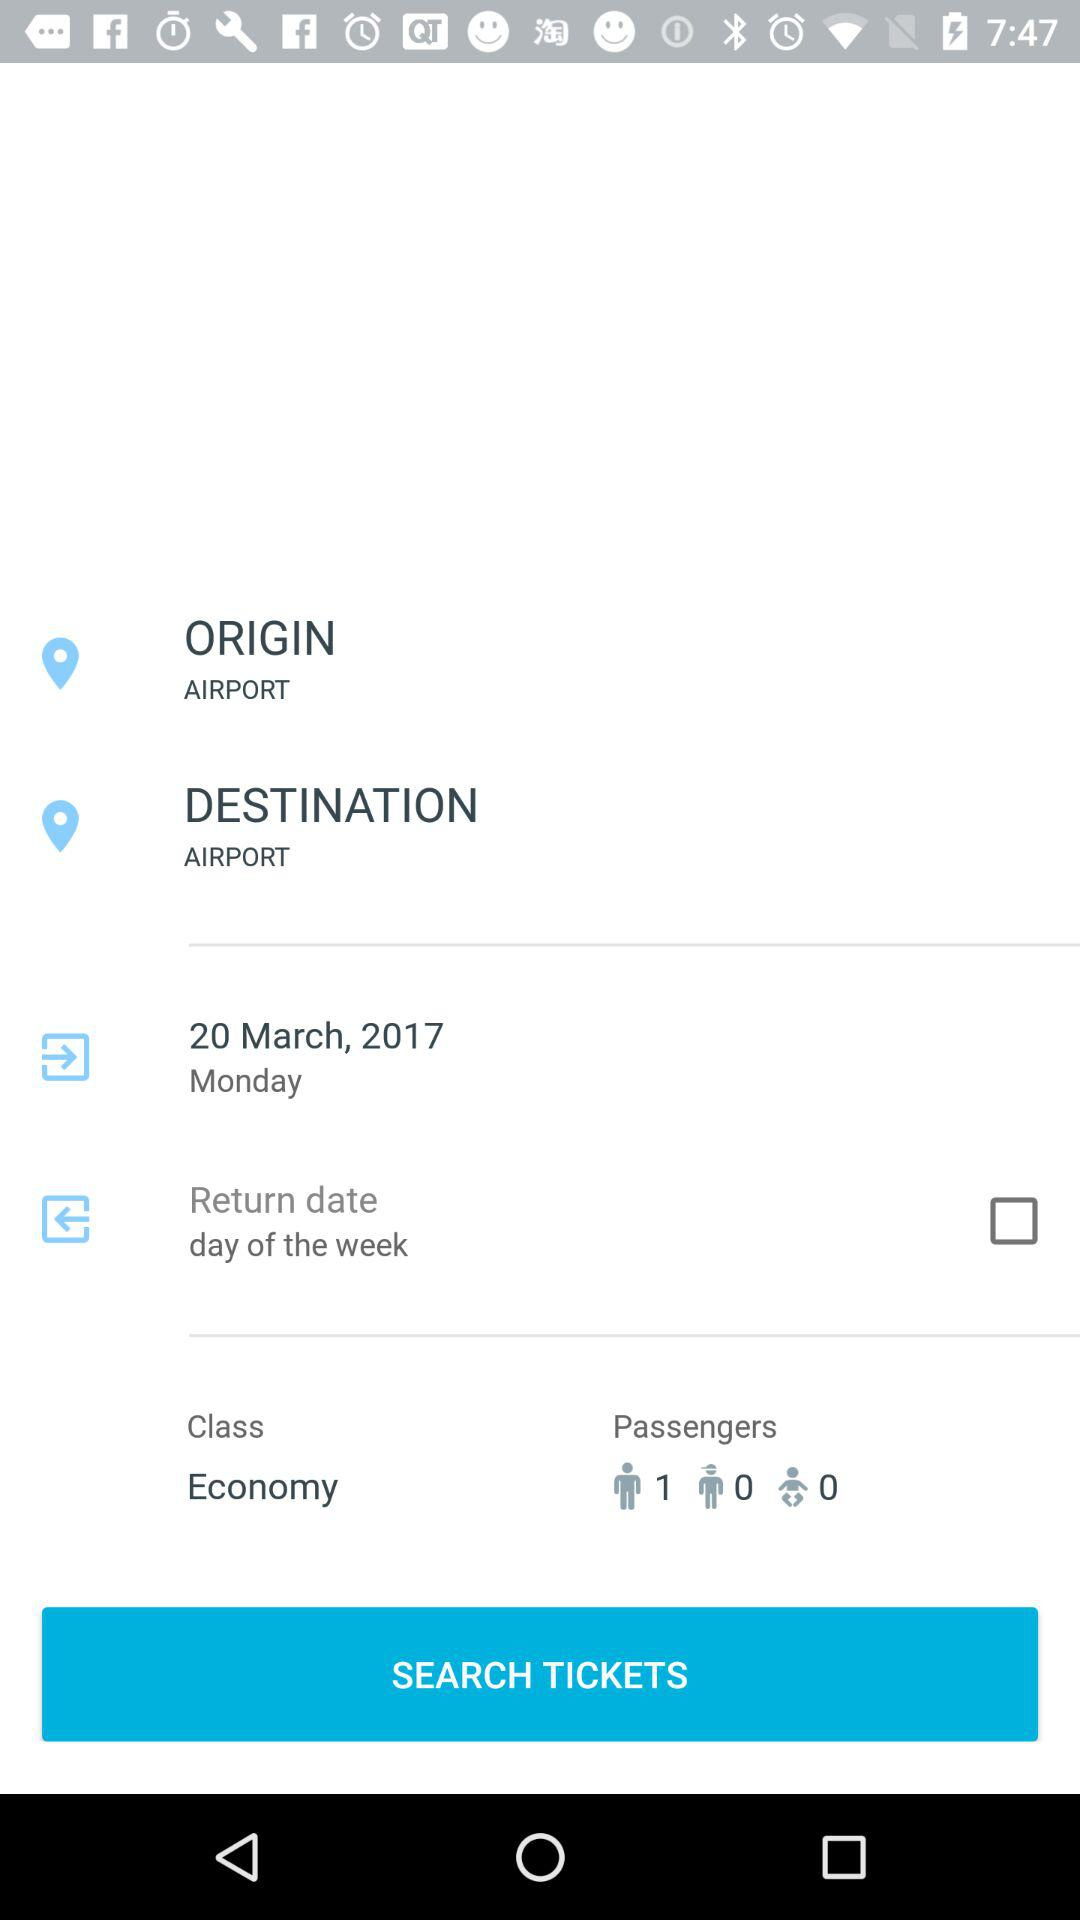How many people are traveling?
Answer the question using a single word or phrase. 1 